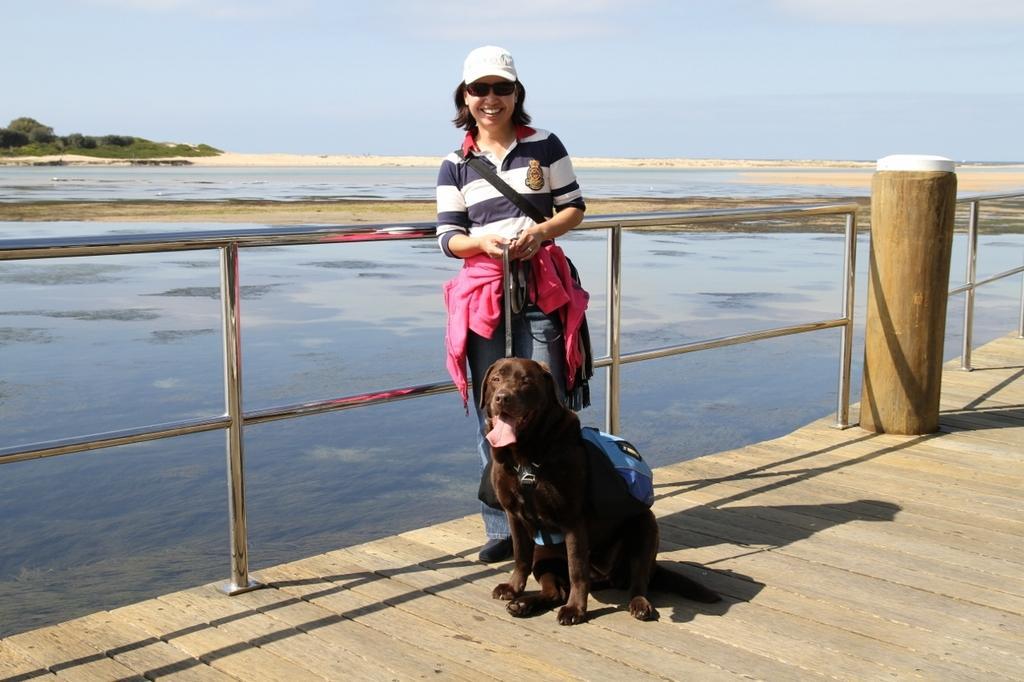Describe this image in one or two sentences. A woman is posing to camera with a dog in front of her and water body at the background. 